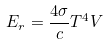<formula> <loc_0><loc_0><loc_500><loc_500>E _ { r } = \frac { 4 \sigma } { c } T ^ { 4 } V</formula> 